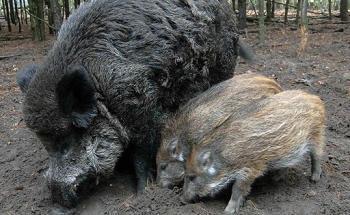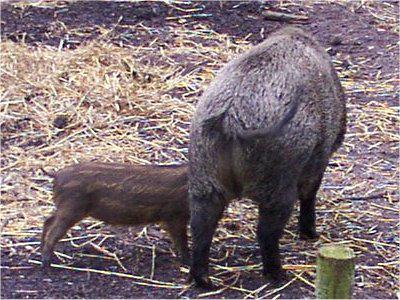The first image is the image on the left, the second image is the image on the right. For the images shown, is this caption "There are at least two striped baby hogs standing next to a black adult hog." true? Answer yes or no. Yes. The first image is the image on the left, the second image is the image on the right. Assess this claim about the two images: "The combined images include at least three piglets standing on all fours, and all piglets are near a standing adult pig.". Correct or not? Answer yes or no. Yes. 